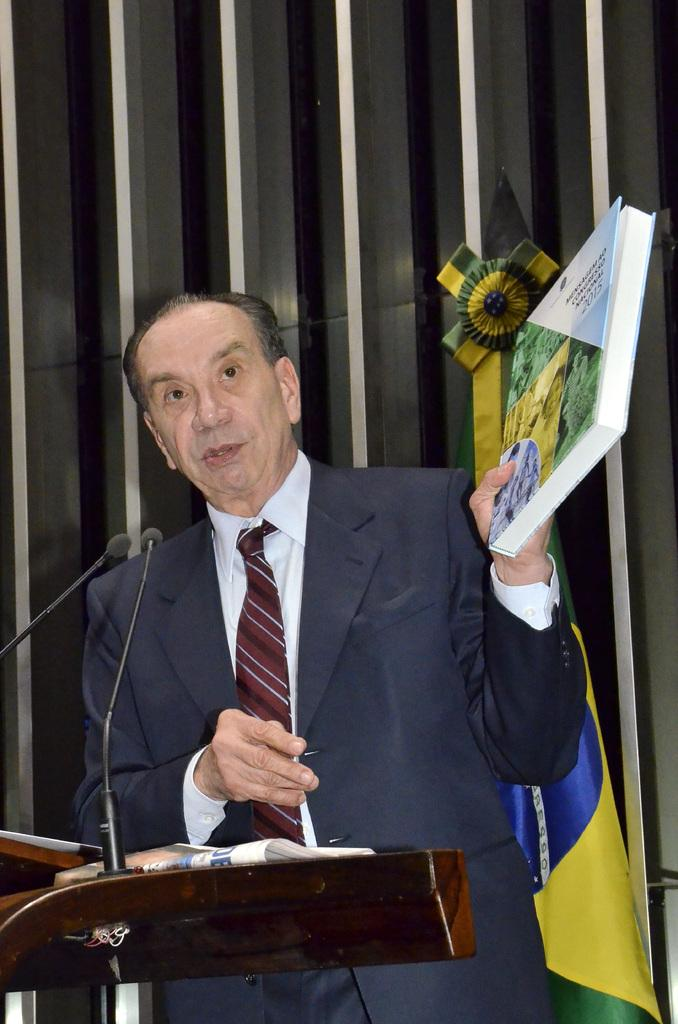Who is present in the image? There is a man in the image. What is the man wearing? The man is wearing a suit. Where is the man standing in the image? The man is standing in front of a dias. What object is on the dias? There is a microphone on the dias. What is the man holding in the image? The man is holding a book. What can be seen in front of a wall in the image? There is a flag in front of a wall. What type of machine is being used for breakfast in the image? There is no machine or breakfast present in the image. Can you describe the wilderness setting in the image? There is no wilderness setting in the image; it features a man standing in front of a dias with a microphone and a flag in front of a wall. 